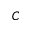Convert formula to latex. <formula><loc_0><loc_0><loc_500><loc_500>C</formula> 